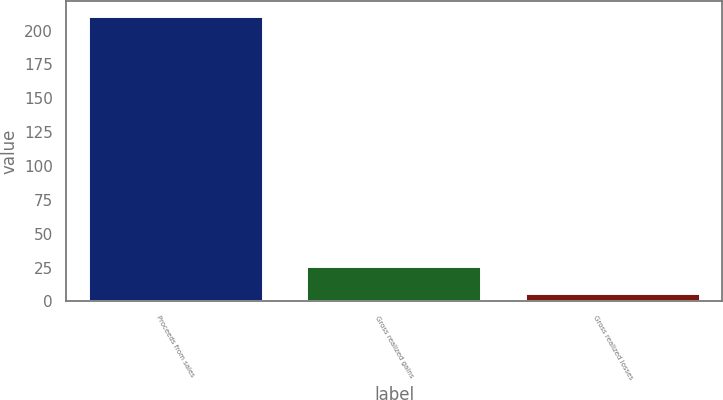<chart> <loc_0><loc_0><loc_500><loc_500><bar_chart><fcel>Proceeds from sales<fcel>Gross realized gains<fcel>Gross realized losses<nl><fcel>211<fcel>26.5<fcel>6<nl></chart> 